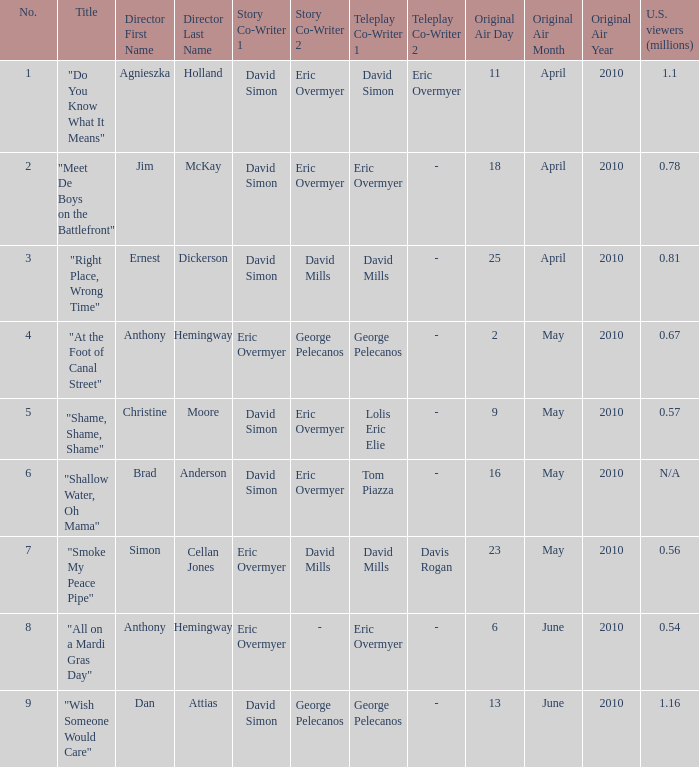Name the teleplay for  david simon & eric overmyer and tom piazza Tom Piazza. 